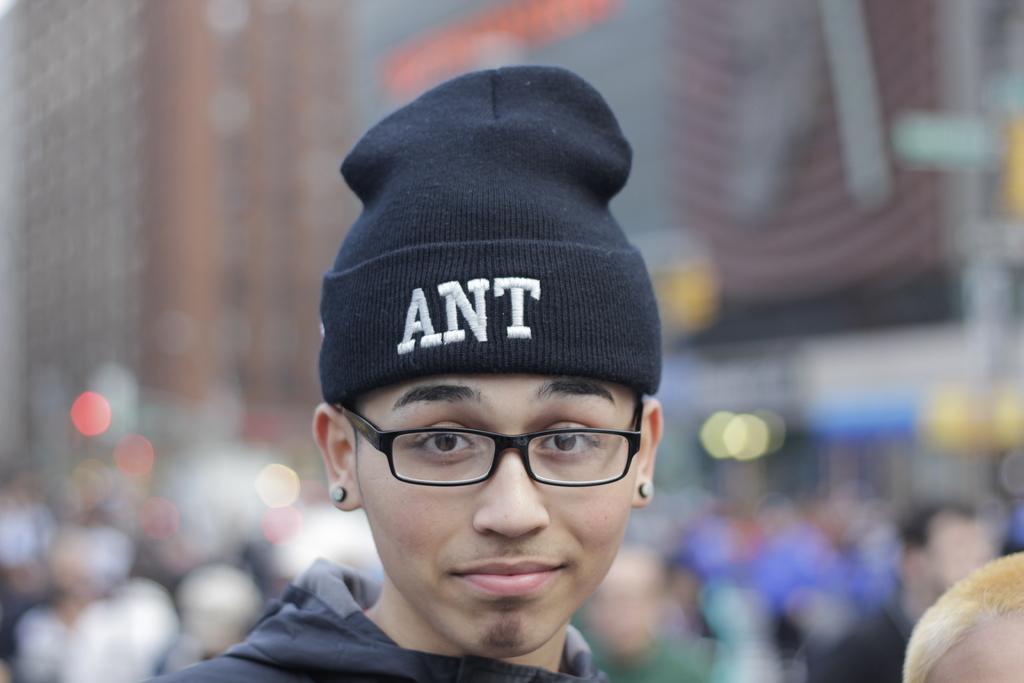Could you give a brief overview of what you see in this image? In this image we can see a person wearing a cap and the spectacles, also we can see the background is blurred. 